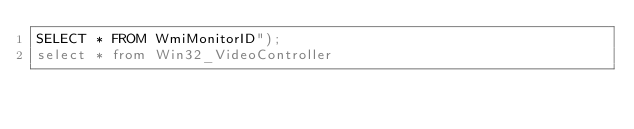<code> <loc_0><loc_0><loc_500><loc_500><_SQL_>SELECT * FROM WmiMonitorID");
select * from Win32_VideoController
</code> 